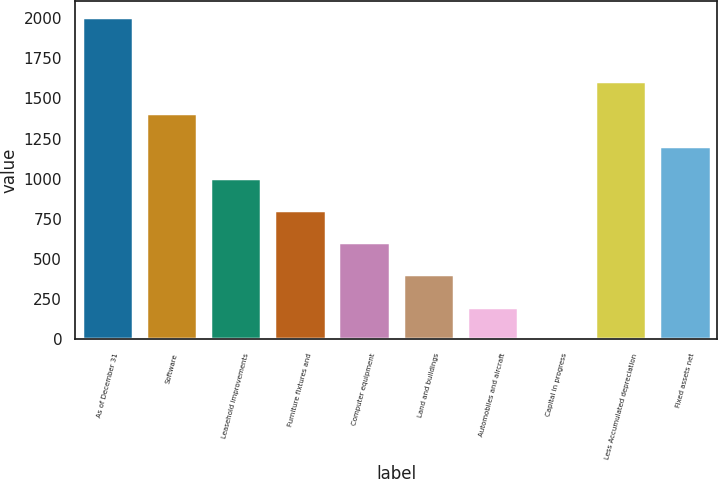Convert chart. <chart><loc_0><loc_0><loc_500><loc_500><bar_chart><fcel>As of December 31<fcel>Software<fcel>Leasehold improvements<fcel>Furniture fixtures and<fcel>Computer equipment<fcel>Land and buildings<fcel>Automobiles and aircraft<fcel>Capital in progress<fcel>Less Accumulated depreciation<fcel>Fixed assets net<nl><fcel>2008<fcel>1406.8<fcel>1006<fcel>805.6<fcel>605.2<fcel>404.8<fcel>204.4<fcel>4<fcel>1607.2<fcel>1206.4<nl></chart> 